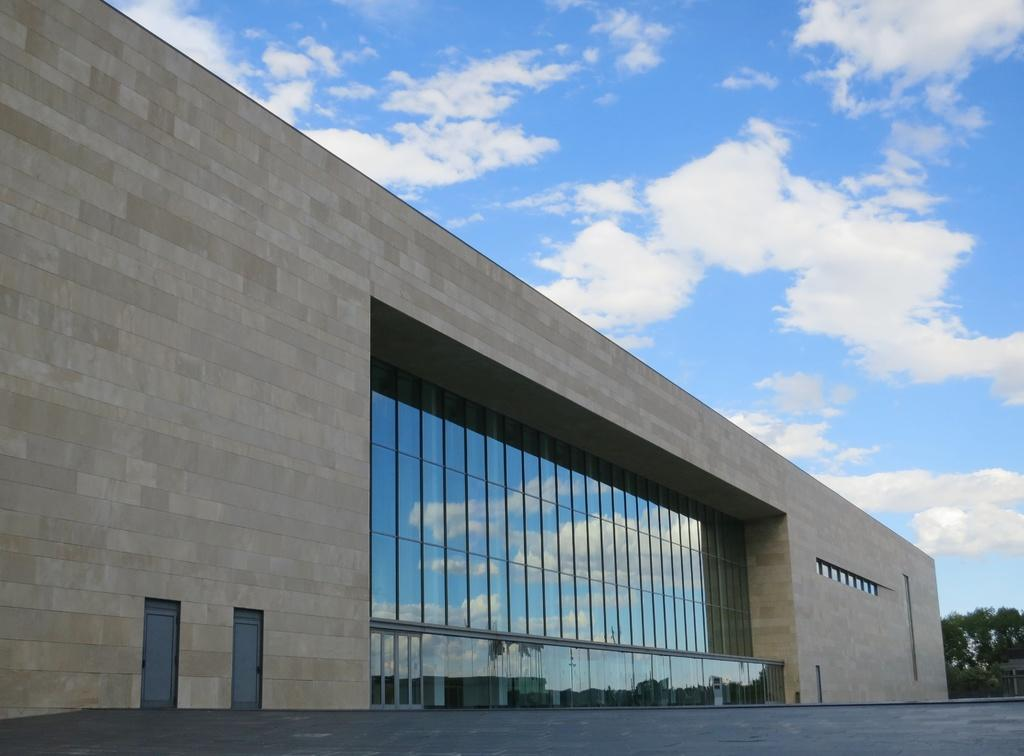What type of structure is present in the image? There is a building in the image. What feature of the building can be seen in the image? There are doors visible in the image. What type of natural elements are present in the image? There are trees in the image. How would you describe the weather in the image? The sky is blue and cloudy in the image, suggesting a partly cloudy day. Can you see a crow stitching a kick in the image? No, there is no crow, stitching, or kick present in the image. 